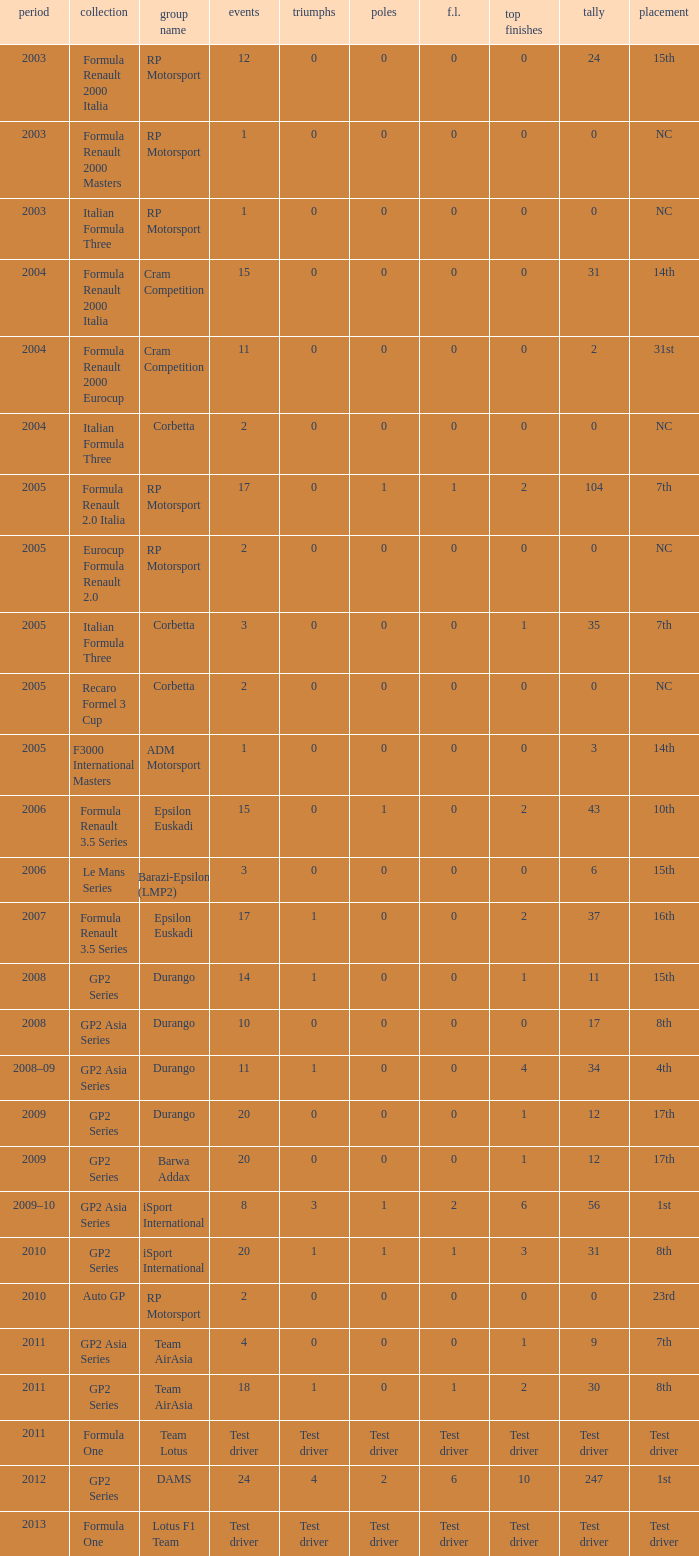What is the number of poles with 4 races? 0.0. 